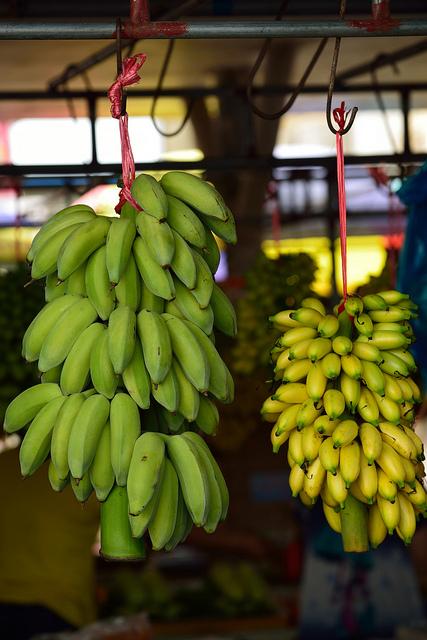Are the ripe bananas big or small?
Keep it brief. Small. What is the color of unripe bananas?
Be succinct. Green. Where are the green bananas?
Be succinct. Hanging. What are the bananas hanging from?
Be succinct. Hooks. Are there any vegetables on this stand?
Give a very brief answer. No. 